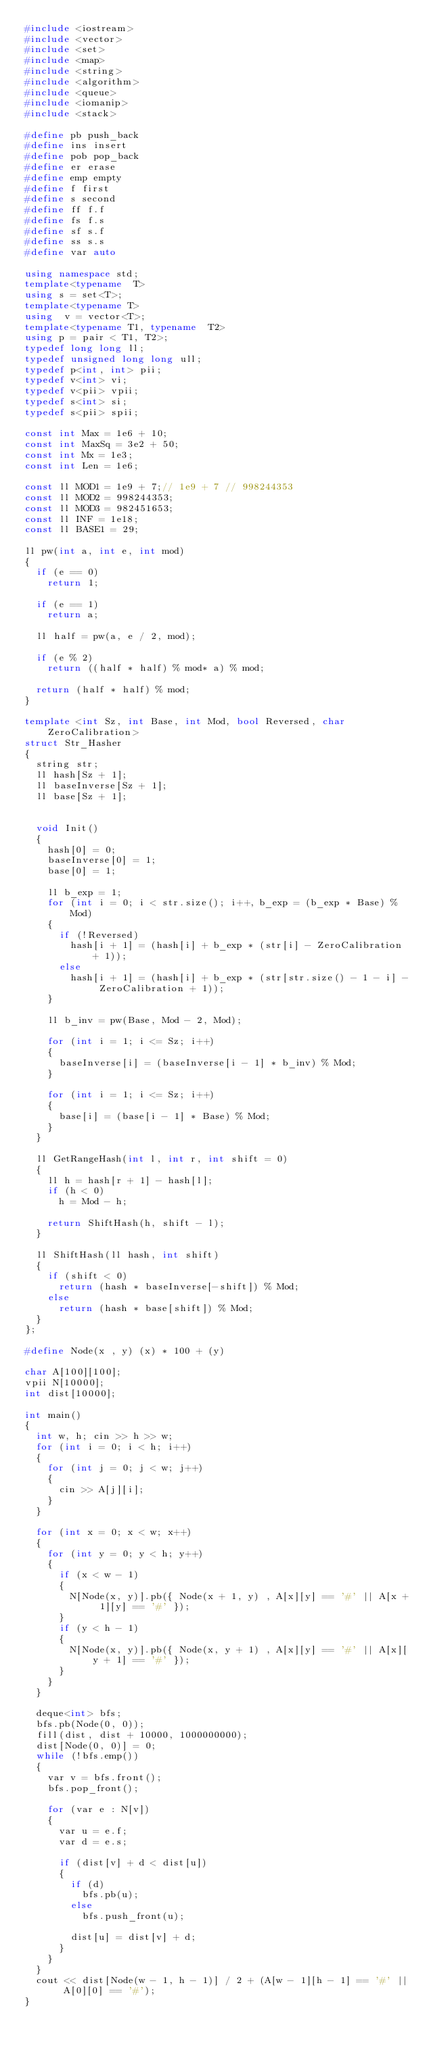<code> <loc_0><loc_0><loc_500><loc_500><_C++_>#include <iostream>
#include <vector>
#include <set>
#include <map>
#include <string>
#include <algorithm>
#include <queue>
#include <iomanip>
#include <stack>

#define pb push_back
#define ins insert
#define pob pop_back
#define er erase
#define emp empty
#define f first
#define s second
#define ff f.f
#define fs f.s
#define sf s.f
#define ss s.s
#define var auto

using namespace std;
template<typename  T>
using s = set<T>;
template<typename T>
using  v = vector<T>;
template<typename T1, typename  T2>
using p = pair < T1, T2>;
typedef long long ll;
typedef unsigned long long ull;
typedef p<int, int> pii;
typedef v<int> vi;
typedef v<pii> vpii;
typedef s<int> si;
typedef s<pii> spii;

const int Max = 1e6 + 10;
const int MaxSq = 3e2 + 50;
const int Mx = 1e3;
const int Len = 1e6;

const ll MOD1 = 1e9 + 7;// 1e9 + 7 // 998244353
const ll MOD2 = 998244353;
const ll MOD3 = 982451653;
const ll INF = 1e18;
const ll BASE1 = 29;

ll pw(int a, int e, int mod)
{
	if (e == 0)
		return 1;

	if (e == 1)
		return a;

	ll half = pw(a, e / 2, mod);

	if (e % 2)
		return ((half * half) % mod* a) % mod;

	return (half * half) % mod;
}

template <int Sz, int Base, int Mod, bool Reversed, char ZeroCalibration>
struct Str_Hasher
{
	string str;
	ll hash[Sz + 1];
	ll baseInverse[Sz + 1];
	ll base[Sz + 1];


	void Init()
	{
		hash[0] = 0;
		baseInverse[0] = 1;
		base[0] = 1;

		ll b_exp = 1;
		for (int i = 0; i < str.size(); i++, b_exp = (b_exp * Base) % Mod)
		{
			if (!Reversed)
				hash[i + 1] = (hash[i] + b_exp * (str[i] - ZeroCalibration + 1));
			else
				hash[i + 1] = (hash[i] + b_exp * (str[str.size() - 1 - i] - ZeroCalibration + 1));
		}

		ll b_inv = pw(Base, Mod - 2, Mod);

		for (int i = 1; i <= Sz; i++)
		{
			baseInverse[i] = (baseInverse[i - 1] * b_inv) % Mod;
		}

		for (int i = 1; i <= Sz; i++)
		{
			base[i] = (base[i - 1] * Base) % Mod;
		}
	}

	ll GetRangeHash(int l, int r, int shift = 0)
	{
		ll h = hash[r + 1] - hash[l];
		if (h < 0)
			h = Mod - h;

		return ShiftHash(h, shift - l);
	}

	ll ShiftHash(ll hash, int shift)
	{
		if (shift < 0)
			return (hash * baseInverse[-shift]) % Mod;
		else
			return (hash * base[shift]) % Mod;
	}
};

#define Node(x , y) (x) * 100 + (y)

char A[100][100];
vpii N[10000];
int dist[10000];

int main()
{
	int w, h; cin >> h >> w;
	for (int i = 0; i < h; i++)
	{
		for (int j = 0; j < w; j++)
		{
			cin >> A[j][i];
		}
	}

	for (int x = 0; x < w; x++)
	{
		for (int y = 0; y < h; y++)
		{
			if (x < w - 1)
			{
				N[Node(x, y)].pb({ Node(x + 1, y) , A[x][y] == '#' || A[x + 1][y] == '#' });
			}
			if (y < h - 1)
			{
				N[Node(x, y)].pb({ Node(x, y + 1) , A[x][y] == '#' || A[x][y + 1] == '#' });
			}
		}
	}

	deque<int> bfs;
	bfs.pb(Node(0, 0));
	fill(dist, dist + 10000, 1000000000);
	dist[Node(0, 0)] = 0;
	while (!bfs.emp())
	{
		var v = bfs.front();
		bfs.pop_front();

		for (var e : N[v])
		{
			var u = e.f;
			var d = e.s;

			if (dist[v] + d < dist[u])
			{
				if (d)
					bfs.pb(u);
				else
					bfs.push_front(u);

				dist[u] = dist[v] + d;
			}
		}
	}
	cout << dist[Node(w - 1, h - 1)] / 2 + (A[w - 1][h - 1] == '#' || A[0][0] == '#');
}
</code> 